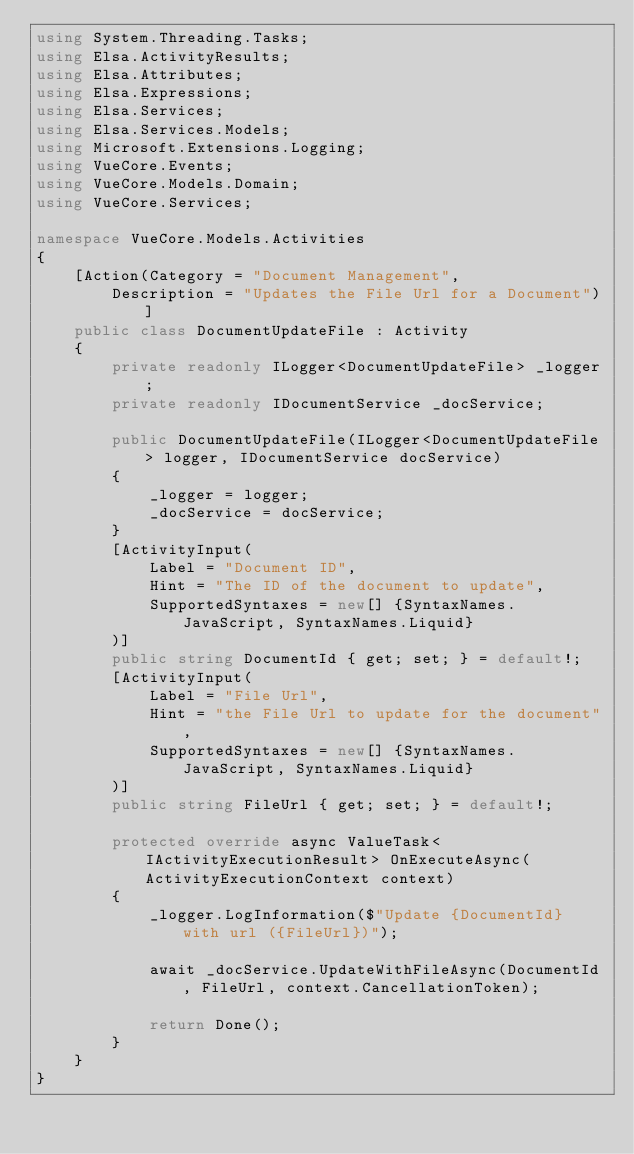Convert code to text. <code><loc_0><loc_0><loc_500><loc_500><_C#_>using System.Threading.Tasks;
using Elsa.ActivityResults;
using Elsa.Attributes;
using Elsa.Expressions;
using Elsa.Services;
using Elsa.Services.Models;
using Microsoft.Extensions.Logging;
using VueCore.Events;
using VueCore.Models.Domain;
using VueCore.Services;

namespace VueCore.Models.Activities
{
    [Action(Category = "Document Management", 
        Description = "Updates the File Url for a Document")]
    public class DocumentUpdateFile : Activity
    {
        private readonly ILogger<DocumentUpdateFile> _logger;
        private readonly IDocumentService _docService;

        public DocumentUpdateFile(ILogger<DocumentUpdateFile> logger, IDocumentService docService)
        {
            _logger = logger;
            _docService = docService;
        }
        [ActivityInput(
            Label = "Document ID",
            Hint = "The ID of the document to update",
            SupportedSyntaxes = new[] {SyntaxNames.JavaScript, SyntaxNames.Liquid}
        )]
        public string DocumentId { get; set; } = default!;
        [ActivityInput(
            Label = "File Url",
            Hint = "the File Url to update for the document",
            SupportedSyntaxes = new[] {SyntaxNames.JavaScript, SyntaxNames.Liquid}
        )]
        public string FileUrl { get; set; } = default!;

        protected override async ValueTask<IActivityExecutionResult> OnExecuteAsync(ActivityExecutionContext context)
        {
            _logger.LogInformation($"Update {DocumentId} with url ({FileUrl})");

            await _docService.UpdateWithFileAsync(DocumentId, FileUrl, context.CancellationToken);

            return Done();
        }
    }
}</code> 